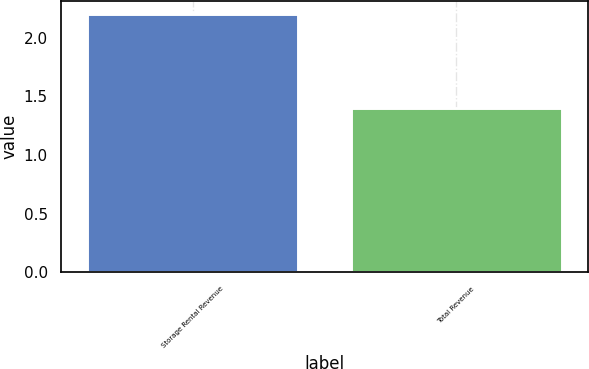Convert chart. <chart><loc_0><loc_0><loc_500><loc_500><bar_chart><fcel>Storage Rental Revenue<fcel>Total Revenue<nl><fcel>2.2<fcel>1.4<nl></chart> 